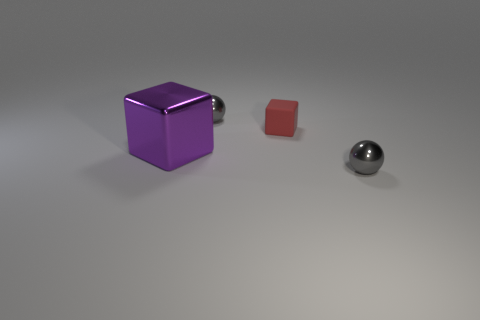How many other things have the same material as the red object?
Keep it short and to the point. 0. Is the ball that is behind the big thing made of the same material as the tiny red cube?
Keep it short and to the point. No. Is there a blue metal ball?
Provide a short and direct response. No. There is a shiny object that is both to the left of the tiny matte block and on the right side of the purple cube; what size is it?
Keep it short and to the point. Small. Are there more red matte things that are left of the shiny block than tiny balls to the right of the rubber thing?
Offer a very short reply. No. What is the color of the matte cube?
Your answer should be compact. Red. There is a thing that is behind the big purple cube and left of the small red object; what is its color?
Ensure brevity in your answer.  Gray. The cube right of the large cube that is in front of the gray shiny sphere that is behind the large purple cube is what color?
Your response must be concise. Red. What is the shape of the gray thing behind the small metal ball in front of the small gray sphere that is behind the purple cube?
Give a very brief answer. Sphere. What number of things are either small shiny cubes or purple metallic cubes to the left of the small cube?
Your answer should be very brief. 1. 